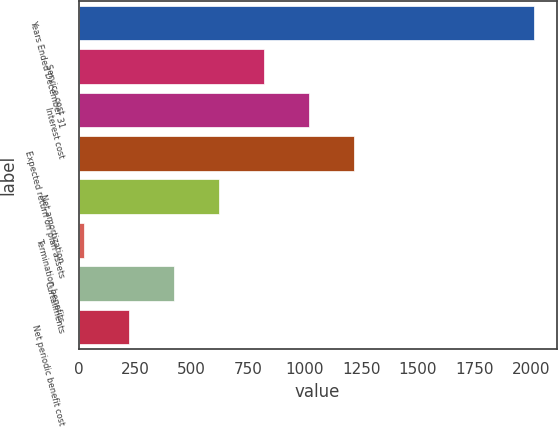Convert chart. <chart><loc_0><loc_0><loc_500><loc_500><bar_chart><fcel>Years Ended December 31<fcel>Service cost<fcel>Interest cost<fcel>Expected return on plan assets<fcel>Net amortization<fcel>Termination benefits<fcel>Curtailments<fcel>Net periodic benefit cost<nl><fcel>2014<fcel>818.8<fcel>1018<fcel>1217.2<fcel>619.6<fcel>22<fcel>420.4<fcel>221.2<nl></chart> 